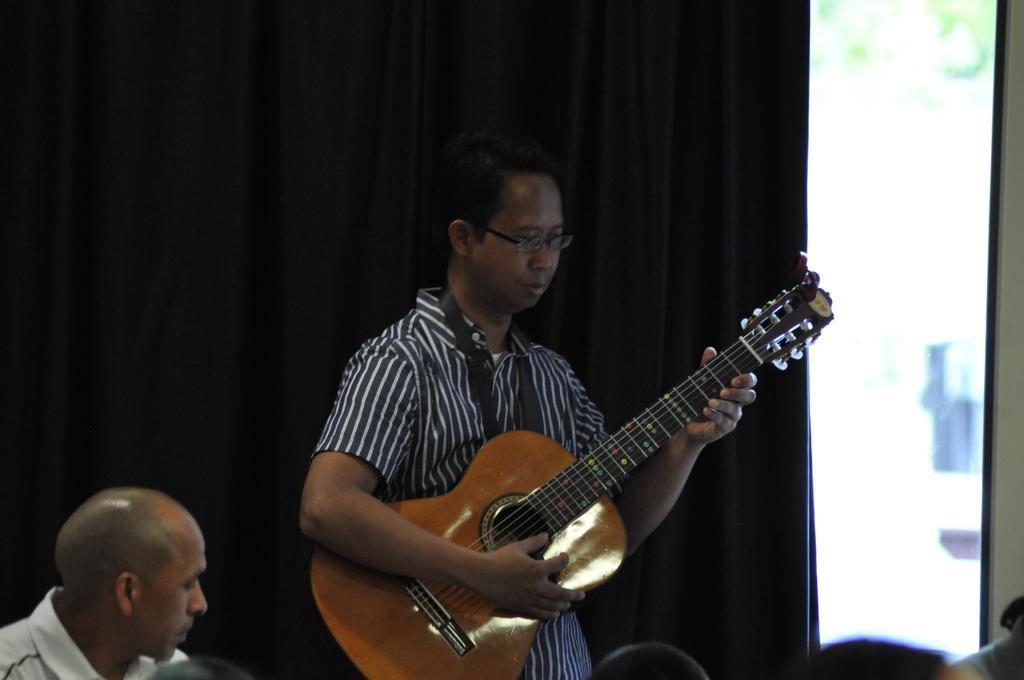How would you summarize this image in a sentence or two? In this image I can see two men where one is standing and holding a guitar. I can also see he is wearing a specs. 